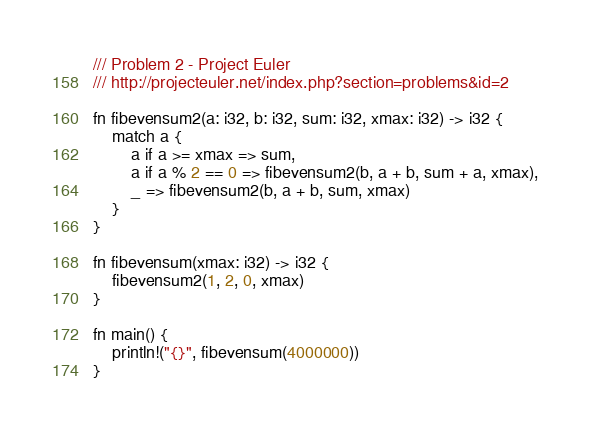<code> <loc_0><loc_0><loc_500><loc_500><_Rust_>/// Problem 2 - Project Euler
/// http://projecteuler.net/index.php?section=problems&id=2

fn fibevensum2(a: i32, b: i32, sum: i32, xmax: i32) -> i32 {
    match a {
        a if a >= xmax => sum,
        a if a % 2 == 0 => fibevensum2(b, a + b, sum + a, xmax),
        _ => fibevensum2(b, a + b, sum, xmax)
    }
}

fn fibevensum(xmax: i32) -> i32 {
    fibevensum2(1, 2, 0, xmax)
}

fn main() {
    println!("{}", fibevensum(4000000))
}
</code> 